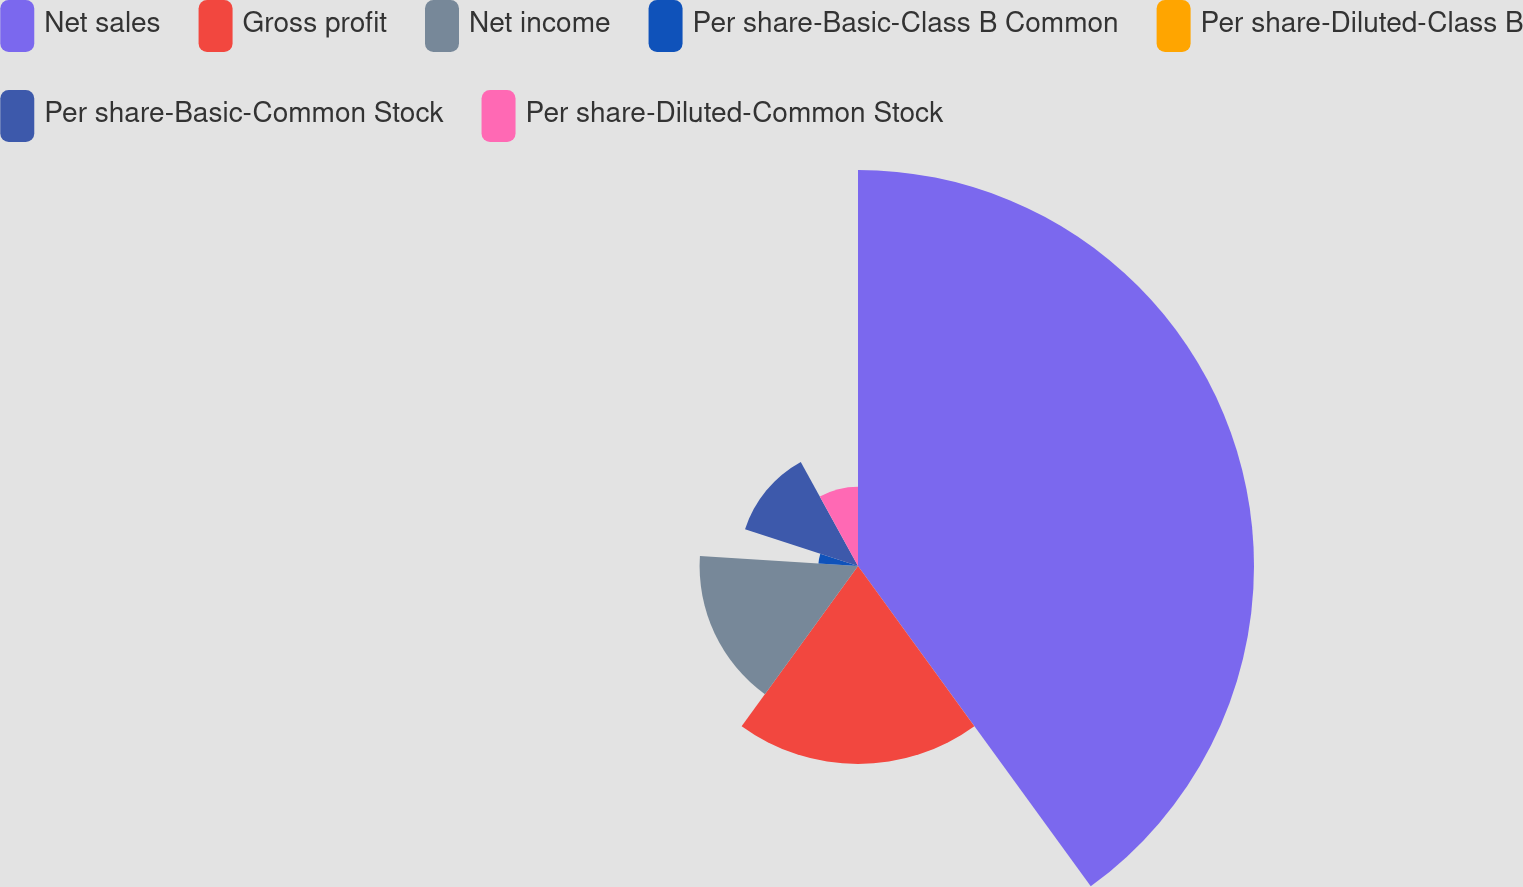Convert chart to OTSL. <chart><loc_0><loc_0><loc_500><loc_500><pie_chart><fcel>Net sales<fcel>Gross profit<fcel>Net income<fcel>Per share-Basic-Class B Common<fcel>Per share-Diluted-Class B<fcel>Per share-Basic-Common Stock<fcel>Per share-Diluted-Common Stock<nl><fcel>40.0%<fcel>20.0%<fcel>16.0%<fcel>4.0%<fcel>0.0%<fcel>12.0%<fcel>8.0%<nl></chart> 